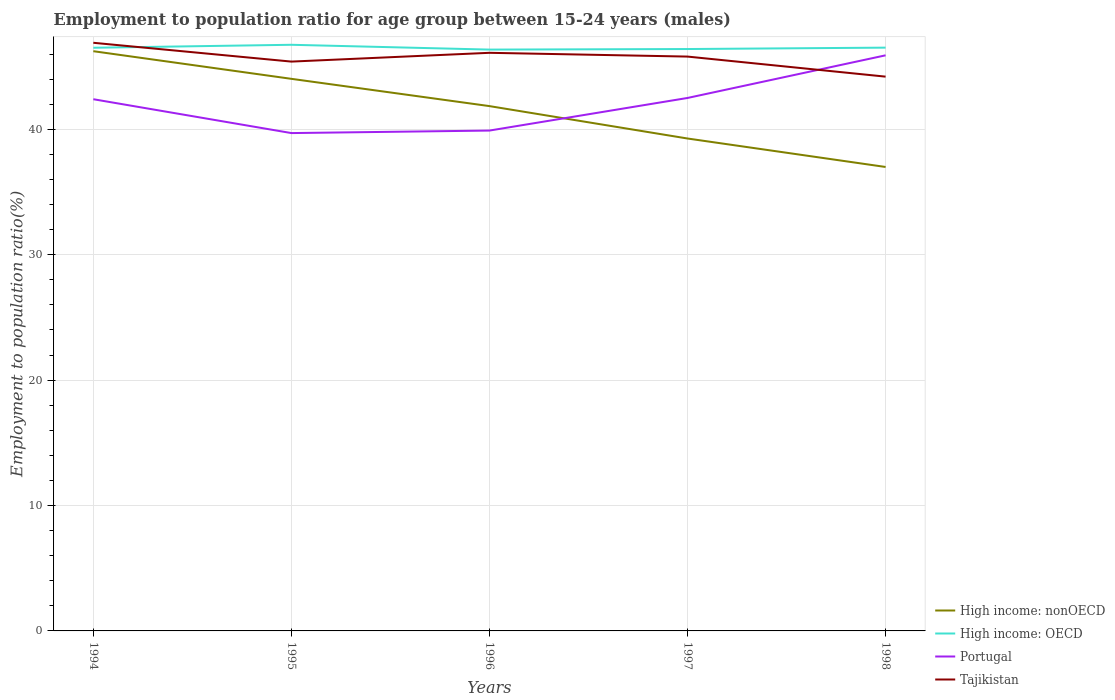How many different coloured lines are there?
Offer a very short reply. 4. Is the number of lines equal to the number of legend labels?
Keep it short and to the point. Yes. Across all years, what is the maximum employment to population ratio in High income: OECD?
Give a very brief answer. 46.36. What is the total employment to population ratio in High income: OECD in the graph?
Provide a succinct answer. -0.24. What is the difference between the highest and the second highest employment to population ratio in High income: OECD?
Provide a succinct answer. 0.38. What is the difference between the highest and the lowest employment to population ratio in Portugal?
Provide a succinct answer. 3. How many years are there in the graph?
Provide a succinct answer. 5. What is the difference between two consecutive major ticks on the Y-axis?
Provide a short and direct response. 10. Are the values on the major ticks of Y-axis written in scientific E-notation?
Give a very brief answer. No. Does the graph contain any zero values?
Ensure brevity in your answer.  No. Does the graph contain grids?
Your response must be concise. Yes. Where does the legend appear in the graph?
Offer a terse response. Bottom right. How many legend labels are there?
Ensure brevity in your answer.  4. How are the legend labels stacked?
Your answer should be compact. Vertical. What is the title of the graph?
Give a very brief answer. Employment to population ratio for age group between 15-24 years (males). What is the label or title of the Y-axis?
Make the answer very short. Employment to population ratio(%). What is the Employment to population ratio(%) of High income: nonOECD in 1994?
Keep it short and to the point. 46.23. What is the Employment to population ratio(%) in High income: OECD in 1994?
Give a very brief answer. 46.5. What is the Employment to population ratio(%) of Portugal in 1994?
Provide a short and direct response. 42.4. What is the Employment to population ratio(%) of Tajikistan in 1994?
Offer a very short reply. 46.9. What is the Employment to population ratio(%) in High income: nonOECD in 1995?
Provide a short and direct response. 44.03. What is the Employment to population ratio(%) of High income: OECD in 1995?
Keep it short and to the point. 46.74. What is the Employment to population ratio(%) of Portugal in 1995?
Your answer should be compact. 39.7. What is the Employment to population ratio(%) in Tajikistan in 1995?
Your response must be concise. 45.4. What is the Employment to population ratio(%) in High income: nonOECD in 1996?
Ensure brevity in your answer.  41.85. What is the Employment to population ratio(%) of High income: OECD in 1996?
Ensure brevity in your answer.  46.36. What is the Employment to population ratio(%) of Portugal in 1996?
Your answer should be compact. 39.9. What is the Employment to population ratio(%) of Tajikistan in 1996?
Ensure brevity in your answer.  46.1. What is the Employment to population ratio(%) in High income: nonOECD in 1997?
Offer a very short reply. 39.27. What is the Employment to population ratio(%) in High income: OECD in 1997?
Your answer should be very brief. 46.4. What is the Employment to population ratio(%) of Portugal in 1997?
Provide a succinct answer. 42.5. What is the Employment to population ratio(%) of Tajikistan in 1997?
Your answer should be compact. 45.8. What is the Employment to population ratio(%) in High income: nonOECD in 1998?
Give a very brief answer. 37. What is the Employment to population ratio(%) in High income: OECD in 1998?
Make the answer very short. 46.51. What is the Employment to population ratio(%) of Portugal in 1998?
Ensure brevity in your answer.  45.9. What is the Employment to population ratio(%) in Tajikistan in 1998?
Give a very brief answer. 44.2. Across all years, what is the maximum Employment to population ratio(%) in High income: nonOECD?
Your response must be concise. 46.23. Across all years, what is the maximum Employment to population ratio(%) of High income: OECD?
Provide a short and direct response. 46.74. Across all years, what is the maximum Employment to population ratio(%) in Portugal?
Make the answer very short. 45.9. Across all years, what is the maximum Employment to population ratio(%) in Tajikistan?
Ensure brevity in your answer.  46.9. Across all years, what is the minimum Employment to population ratio(%) of High income: nonOECD?
Offer a very short reply. 37. Across all years, what is the minimum Employment to population ratio(%) in High income: OECD?
Provide a short and direct response. 46.36. Across all years, what is the minimum Employment to population ratio(%) of Portugal?
Ensure brevity in your answer.  39.7. Across all years, what is the minimum Employment to population ratio(%) in Tajikistan?
Ensure brevity in your answer.  44.2. What is the total Employment to population ratio(%) in High income: nonOECD in the graph?
Give a very brief answer. 208.37. What is the total Employment to population ratio(%) in High income: OECD in the graph?
Your answer should be very brief. 232.52. What is the total Employment to population ratio(%) of Portugal in the graph?
Ensure brevity in your answer.  210.4. What is the total Employment to population ratio(%) in Tajikistan in the graph?
Your response must be concise. 228.4. What is the difference between the Employment to population ratio(%) of High income: nonOECD in 1994 and that in 1995?
Ensure brevity in your answer.  2.2. What is the difference between the Employment to population ratio(%) in High income: OECD in 1994 and that in 1995?
Keep it short and to the point. -0.24. What is the difference between the Employment to population ratio(%) of Portugal in 1994 and that in 1995?
Provide a succinct answer. 2.7. What is the difference between the Employment to population ratio(%) in High income: nonOECD in 1994 and that in 1996?
Keep it short and to the point. 4.38. What is the difference between the Employment to population ratio(%) of High income: OECD in 1994 and that in 1996?
Provide a short and direct response. 0.15. What is the difference between the Employment to population ratio(%) of Tajikistan in 1994 and that in 1996?
Give a very brief answer. 0.8. What is the difference between the Employment to population ratio(%) of High income: nonOECD in 1994 and that in 1997?
Ensure brevity in your answer.  6.96. What is the difference between the Employment to population ratio(%) in High income: OECD in 1994 and that in 1997?
Your answer should be very brief. 0.1. What is the difference between the Employment to population ratio(%) of Portugal in 1994 and that in 1997?
Ensure brevity in your answer.  -0.1. What is the difference between the Employment to population ratio(%) of Tajikistan in 1994 and that in 1997?
Provide a succinct answer. 1.1. What is the difference between the Employment to population ratio(%) in High income: nonOECD in 1994 and that in 1998?
Ensure brevity in your answer.  9.23. What is the difference between the Employment to population ratio(%) in High income: OECD in 1994 and that in 1998?
Ensure brevity in your answer.  -0.01. What is the difference between the Employment to population ratio(%) in High income: nonOECD in 1995 and that in 1996?
Provide a short and direct response. 2.17. What is the difference between the Employment to population ratio(%) of High income: OECD in 1995 and that in 1996?
Provide a succinct answer. 0.38. What is the difference between the Employment to population ratio(%) of Portugal in 1995 and that in 1996?
Keep it short and to the point. -0.2. What is the difference between the Employment to population ratio(%) of Tajikistan in 1995 and that in 1996?
Your answer should be compact. -0.7. What is the difference between the Employment to population ratio(%) in High income: nonOECD in 1995 and that in 1997?
Provide a short and direct response. 4.76. What is the difference between the Employment to population ratio(%) in High income: OECD in 1995 and that in 1997?
Provide a succinct answer. 0.34. What is the difference between the Employment to population ratio(%) in Portugal in 1995 and that in 1997?
Your response must be concise. -2.8. What is the difference between the Employment to population ratio(%) in Tajikistan in 1995 and that in 1997?
Provide a succinct answer. -0.4. What is the difference between the Employment to population ratio(%) in High income: nonOECD in 1995 and that in 1998?
Provide a short and direct response. 7.03. What is the difference between the Employment to population ratio(%) of High income: OECD in 1995 and that in 1998?
Ensure brevity in your answer.  0.23. What is the difference between the Employment to population ratio(%) of High income: nonOECD in 1996 and that in 1997?
Provide a succinct answer. 2.58. What is the difference between the Employment to population ratio(%) of High income: OECD in 1996 and that in 1997?
Make the answer very short. -0.04. What is the difference between the Employment to population ratio(%) of Tajikistan in 1996 and that in 1997?
Make the answer very short. 0.3. What is the difference between the Employment to population ratio(%) of High income: nonOECD in 1996 and that in 1998?
Your answer should be compact. 4.85. What is the difference between the Employment to population ratio(%) of High income: OECD in 1996 and that in 1998?
Your answer should be very brief. -0.16. What is the difference between the Employment to population ratio(%) in Portugal in 1996 and that in 1998?
Make the answer very short. -6. What is the difference between the Employment to population ratio(%) of High income: nonOECD in 1997 and that in 1998?
Provide a short and direct response. 2.27. What is the difference between the Employment to population ratio(%) in High income: OECD in 1997 and that in 1998?
Provide a short and direct response. -0.11. What is the difference between the Employment to population ratio(%) of High income: nonOECD in 1994 and the Employment to population ratio(%) of High income: OECD in 1995?
Give a very brief answer. -0.51. What is the difference between the Employment to population ratio(%) in High income: nonOECD in 1994 and the Employment to population ratio(%) in Portugal in 1995?
Your answer should be very brief. 6.53. What is the difference between the Employment to population ratio(%) in High income: nonOECD in 1994 and the Employment to population ratio(%) in Tajikistan in 1995?
Make the answer very short. 0.83. What is the difference between the Employment to population ratio(%) in High income: OECD in 1994 and the Employment to population ratio(%) in Portugal in 1995?
Provide a short and direct response. 6.8. What is the difference between the Employment to population ratio(%) of High income: OECD in 1994 and the Employment to population ratio(%) of Tajikistan in 1995?
Offer a terse response. 1.1. What is the difference between the Employment to population ratio(%) in High income: nonOECD in 1994 and the Employment to population ratio(%) in High income: OECD in 1996?
Provide a short and direct response. -0.13. What is the difference between the Employment to population ratio(%) of High income: nonOECD in 1994 and the Employment to population ratio(%) of Portugal in 1996?
Your answer should be compact. 6.33. What is the difference between the Employment to population ratio(%) in High income: nonOECD in 1994 and the Employment to population ratio(%) in Tajikistan in 1996?
Offer a terse response. 0.13. What is the difference between the Employment to population ratio(%) of High income: OECD in 1994 and the Employment to population ratio(%) of Portugal in 1996?
Keep it short and to the point. 6.6. What is the difference between the Employment to population ratio(%) of High income: OECD in 1994 and the Employment to population ratio(%) of Tajikistan in 1996?
Your answer should be compact. 0.4. What is the difference between the Employment to population ratio(%) in Portugal in 1994 and the Employment to population ratio(%) in Tajikistan in 1996?
Keep it short and to the point. -3.7. What is the difference between the Employment to population ratio(%) in High income: nonOECD in 1994 and the Employment to population ratio(%) in High income: OECD in 1997?
Ensure brevity in your answer.  -0.17. What is the difference between the Employment to population ratio(%) of High income: nonOECD in 1994 and the Employment to population ratio(%) of Portugal in 1997?
Make the answer very short. 3.73. What is the difference between the Employment to population ratio(%) in High income: nonOECD in 1994 and the Employment to population ratio(%) in Tajikistan in 1997?
Provide a succinct answer. 0.43. What is the difference between the Employment to population ratio(%) in High income: OECD in 1994 and the Employment to population ratio(%) in Portugal in 1997?
Offer a terse response. 4. What is the difference between the Employment to population ratio(%) in High income: OECD in 1994 and the Employment to population ratio(%) in Tajikistan in 1997?
Provide a succinct answer. 0.7. What is the difference between the Employment to population ratio(%) in Portugal in 1994 and the Employment to population ratio(%) in Tajikistan in 1997?
Keep it short and to the point. -3.4. What is the difference between the Employment to population ratio(%) in High income: nonOECD in 1994 and the Employment to population ratio(%) in High income: OECD in 1998?
Make the answer very short. -0.28. What is the difference between the Employment to population ratio(%) in High income: nonOECD in 1994 and the Employment to population ratio(%) in Portugal in 1998?
Make the answer very short. 0.33. What is the difference between the Employment to population ratio(%) of High income: nonOECD in 1994 and the Employment to population ratio(%) of Tajikistan in 1998?
Your response must be concise. 2.03. What is the difference between the Employment to population ratio(%) in High income: OECD in 1994 and the Employment to population ratio(%) in Portugal in 1998?
Offer a terse response. 0.6. What is the difference between the Employment to population ratio(%) of High income: OECD in 1994 and the Employment to population ratio(%) of Tajikistan in 1998?
Provide a short and direct response. 2.3. What is the difference between the Employment to population ratio(%) of Portugal in 1994 and the Employment to population ratio(%) of Tajikistan in 1998?
Provide a short and direct response. -1.8. What is the difference between the Employment to population ratio(%) in High income: nonOECD in 1995 and the Employment to population ratio(%) in High income: OECD in 1996?
Offer a very short reply. -2.33. What is the difference between the Employment to population ratio(%) of High income: nonOECD in 1995 and the Employment to population ratio(%) of Portugal in 1996?
Provide a short and direct response. 4.13. What is the difference between the Employment to population ratio(%) of High income: nonOECD in 1995 and the Employment to population ratio(%) of Tajikistan in 1996?
Provide a succinct answer. -2.07. What is the difference between the Employment to population ratio(%) in High income: OECD in 1995 and the Employment to population ratio(%) in Portugal in 1996?
Ensure brevity in your answer.  6.84. What is the difference between the Employment to population ratio(%) of High income: OECD in 1995 and the Employment to population ratio(%) of Tajikistan in 1996?
Give a very brief answer. 0.64. What is the difference between the Employment to population ratio(%) of Portugal in 1995 and the Employment to population ratio(%) of Tajikistan in 1996?
Provide a short and direct response. -6.4. What is the difference between the Employment to population ratio(%) of High income: nonOECD in 1995 and the Employment to population ratio(%) of High income: OECD in 1997?
Provide a short and direct response. -2.38. What is the difference between the Employment to population ratio(%) in High income: nonOECD in 1995 and the Employment to population ratio(%) in Portugal in 1997?
Provide a short and direct response. 1.53. What is the difference between the Employment to population ratio(%) in High income: nonOECD in 1995 and the Employment to population ratio(%) in Tajikistan in 1997?
Provide a short and direct response. -1.77. What is the difference between the Employment to population ratio(%) of High income: OECD in 1995 and the Employment to population ratio(%) of Portugal in 1997?
Make the answer very short. 4.24. What is the difference between the Employment to population ratio(%) of High income: OECD in 1995 and the Employment to population ratio(%) of Tajikistan in 1997?
Keep it short and to the point. 0.94. What is the difference between the Employment to population ratio(%) of High income: nonOECD in 1995 and the Employment to population ratio(%) of High income: OECD in 1998?
Provide a succinct answer. -2.49. What is the difference between the Employment to population ratio(%) in High income: nonOECD in 1995 and the Employment to population ratio(%) in Portugal in 1998?
Make the answer very short. -1.87. What is the difference between the Employment to population ratio(%) in High income: nonOECD in 1995 and the Employment to population ratio(%) in Tajikistan in 1998?
Your answer should be compact. -0.17. What is the difference between the Employment to population ratio(%) of High income: OECD in 1995 and the Employment to population ratio(%) of Portugal in 1998?
Your answer should be very brief. 0.84. What is the difference between the Employment to population ratio(%) of High income: OECD in 1995 and the Employment to population ratio(%) of Tajikistan in 1998?
Offer a terse response. 2.54. What is the difference between the Employment to population ratio(%) in High income: nonOECD in 1996 and the Employment to population ratio(%) in High income: OECD in 1997?
Ensure brevity in your answer.  -4.55. What is the difference between the Employment to population ratio(%) in High income: nonOECD in 1996 and the Employment to population ratio(%) in Portugal in 1997?
Provide a succinct answer. -0.65. What is the difference between the Employment to population ratio(%) of High income: nonOECD in 1996 and the Employment to population ratio(%) of Tajikistan in 1997?
Keep it short and to the point. -3.95. What is the difference between the Employment to population ratio(%) in High income: OECD in 1996 and the Employment to population ratio(%) in Portugal in 1997?
Offer a very short reply. 3.86. What is the difference between the Employment to population ratio(%) of High income: OECD in 1996 and the Employment to population ratio(%) of Tajikistan in 1997?
Provide a succinct answer. 0.56. What is the difference between the Employment to population ratio(%) in High income: nonOECD in 1996 and the Employment to population ratio(%) in High income: OECD in 1998?
Offer a terse response. -4.66. What is the difference between the Employment to population ratio(%) in High income: nonOECD in 1996 and the Employment to population ratio(%) in Portugal in 1998?
Give a very brief answer. -4.05. What is the difference between the Employment to population ratio(%) of High income: nonOECD in 1996 and the Employment to population ratio(%) of Tajikistan in 1998?
Ensure brevity in your answer.  -2.35. What is the difference between the Employment to population ratio(%) in High income: OECD in 1996 and the Employment to population ratio(%) in Portugal in 1998?
Your response must be concise. 0.46. What is the difference between the Employment to population ratio(%) of High income: OECD in 1996 and the Employment to population ratio(%) of Tajikistan in 1998?
Your answer should be very brief. 2.16. What is the difference between the Employment to population ratio(%) in High income: nonOECD in 1997 and the Employment to population ratio(%) in High income: OECD in 1998?
Provide a short and direct response. -7.25. What is the difference between the Employment to population ratio(%) of High income: nonOECD in 1997 and the Employment to population ratio(%) of Portugal in 1998?
Ensure brevity in your answer.  -6.63. What is the difference between the Employment to population ratio(%) of High income: nonOECD in 1997 and the Employment to population ratio(%) of Tajikistan in 1998?
Offer a very short reply. -4.93. What is the difference between the Employment to population ratio(%) of High income: OECD in 1997 and the Employment to population ratio(%) of Portugal in 1998?
Provide a succinct answer. 0.5. What is the difference between the Employment to population ratio(%) in High income: OECD in 1997 and the Employment to population ratio(%) in Tajikistan in 1998?
Ensure brevity in your answer.  2.2. What is the average Employment to population ratio(%) of High income: nonOECD per year?
Provide a short and direct response. 41.67. What is the average Employment to population ratio(%) in High income: OECD per year?
Keep it short and to the point. 46.5. What is the average Employment to population ratio(%) of Portugal per year?
Offer a terse response. 42.08. What is the average Employment to population ratio(%) of Tajikistan per year?
Your answer should be very brief. 45.68. In the year 1994, what is the difference between the Employment to population ratio(%) of High income: nonOECD and Employment to population ratio(%) of High income: OECD?
Make the answer very short. -0.27. In the year 1994, what is the difference between the Employment to population ratio(%) in High income: nonOECD and Employment to population ratio(%) in Portugal?
Offer a very short reply. 3.83. In the year 1994, what is the difference between the Employment to population ratio(%) in High income: nonOECD and Employment to population ratio(%) in Tajikistan?
Your answer should be compact. -0.67. In the year 1994, what is the difference between the Employment to population ratio(%) of High income: OECD and Employment to population ratio(%) of Portugal?
Offer a very short reply. 4.1. In the year 1994, what is the difference between the Employment to population ratio(%) of High income: OECD and Employment to population ratio(%) of Tajikistan?
Offer a very short reply. -0.4. In the year 1995, what is the difference between the Employment to population ratio(%) of High income: nonOECD and Employment to population ratio(%) of High income: OECD?
Provide a short and direct response. -2.72. In the year 1995, what is the difference between the Employment to population ratio(%) in High income: nonOECD and Employment to population ratio(%) in Portugal?
Keep it short and to the point. 4.33. In the year 1995, what is the difference between the Employment to population ratio(%) of High income: nonOECD and Employment to population ratio(%) of Tajikistan?
Make the answer very short. -1.37. In the year 1995, what is the difference between the Employment to population ratio(%) in High income: OECD and Employment to population ratio(%) in Portugal?
Make the answer very short. 7.04. In the year 1995, what is the difference between the Employment to population ratio(%) in High income: OECD and Employment to population ratio(%) in Tajikistan?
Your answer should be compact. 1.34. In the year 1995, what is the difference between the Employment to population ratio(%) in Portugal and Employment to population ratio(%) in Tajikistan?
Offer a terse response. -5.7. In the year 1996, what is the difference between the Employment to population ratio(%) in High income: nonOECD and Employment to population ratio(%) in High income: OECD?
Keep it short and to the point. -4.51. In the year 1996, what is the difference between the Employment to population ratio(%) in High income: nonOECD and Employment to population ratio(%) in Portugal?
Provide a short and direct response. 1.95. In the year 1996, what is the difference between the Employment to population ratio(%) in High income: nonOECD and Employment to population ratio(%) in Tajikistan?
Give a very brief answer. -4.25. In the year 1996, what is the difference between the Employment to population ratio(%) of High income: OECD and Employment to population ratio(%) of Portugal?
Your answer should be very brief. 6.46. In the year 1996, what is the difference between the Employment to population ratio(%) in High income: OECD and Employment to population ratio(%) in Tajikistan?
Your response must be concise. 0.26. In the year 1997, what is the difference between the Employment to population ratio(%) in High income: nonOECD and Employment to population ratio(%) in High income: OECD?
Offer a terse response. -7.13. In the year 1997, what is the difference between the Employment to population ratio(%) in High income: nonOECD and Employment to population ratio(%) in Portugal?
Provide a short and direct response. -3.23. In the year 1997, what is the difference between the Employment to population ratio(%) in High income: nonOECD and Employment to population ratio(%) in Tajikistan?
Your response must be concise. -6.53. In the year 1997, what is the difference between the Employment to population ratio(%) in High income: OECD and Employment to population ratio(%) in Portugal?
Make the answer very short. 3.9. In the year 1997, what is the difference between the Employment to population ratio(%) of High income: OECD and Employment to population ratio(%) of Tajikistan?
Keep it short and to the point. 0.6. In the year 1997, what is the difference between the Employment to population ratio(%) of Portugal and Employment to population ratio(%) of Tajikistan?
Provide a succinct answer. -3.3. In the year 1998, what is the difference between the Employment to population ratio(%) in High income: nonOECD and Employment to population ratio(%) in High income: OECD?
Ensure brevity in your answer.  -9.52. In the year 1998, what is the difference between the Employment to population ratio(%) in High income: nonOECD and Employment to population ratio(%) in Portugal?
Make the answer very short. -8.9. In the year 1998, what is the difference between the Employment to population ratio(%) of High income: nonOECD and Employment to population ratio(%) of Tajikistan?
Provide a short and direct response. -7.2. In the year 1998, what is the difference between the Employment to population ratio(%) of High income: OECD and Employment to population ratio(%) of Portugal?
Offer a very short reply. 0.61. In the year 1998, what is the difference between the Employment to population ratio(%) of High income: OECD and Employment to population ratio(%) of Tajikistan?
Your response must be concise. 2.31. What is the ratio of the Employment to population ratio(%) of High income: nonOECD in 1994 to that in 1995?
Offer a very short reply. 1.05. What is the ratio of the Employment to population ratio(%) in Portugal in 1994 to that in 1995?
Offer a very short reply. 1.07. What is the ratio of the Employment to population ratio(%) in Tajikistan in 1994 to that in 1995?
Make the answer very short. 1.03. What is the ratio of the Employment to population ratio(%) in High income: nonOECD in 1994 to that in 1996?
Your response must be concise. 1.1. What is the ratio of the Employment to population ratio(%) in Portugal in 1994 to that in 1996?
Give a very brief answer. 1.06. What is the ratio of the Employment to population ratio(%) in Tajikistan in 1994 to that in 1996?
Ensure brevity in your answer.  1.02. What is the ratio of the Employment to population ratio(%) of High income: nonOECD in 1994 to that in 1997?
Provide a short and direct response. 1.18. What is the ratio of the Employment to population ratio(%) in High income: OECD in 1994 to that in 1997?
Provide a short and direct response. 1. What is the ratio of the Employment to population ratio(%) in Portugal in 1994 to that in 1997?
Keep it short and to the point. 1. What is the ratio of the Employment to population ratio(%) of Tajikistan in 1994 to that in 1997?
Ensure brevity in your answer.  1.02. What is the ratio of the Employment to population ratio(%) in High income: nonOECD in 1994 to that in 1998?
Keep it short and to the point. 1.25. What is the ratio of the Employment to population ratio(%) of Portugal in 1994 to that in 1998?
Keep it short and to the point. 0.92. What is the ratio of the Employment to population ratio(%) in Tajikistan in 1994 to that in 1998?
Provide a short and direct response. 1.06. What is the ratio of the Employment to population ratio(%) in High income: nonOECD in 1995 to that in 1996?
Keep it short and to the point. 1.05. What is the ratio of the Employment to population ratio(%) of High income: OECD in 1995 to that in 1996?
Make the answer very short. 1.01. What is the ratio of the Employment to population ratio(%) in Portugal in 1995 to that in 1996?
Provide a succinct answer. 0.99. What is the ratio of the Employment to population ratio(%) of High income: nonOECD in 1995 to that in 1997?
Your response must be concise. 1.12. What is the ratio of the Employment to population ratio(%) of High income: OECD in 1995 to that in 1997?
Your answer should be very brief. 1.01. What is the ratio of the Employment to population ratio(%) in Portugal in 1995 to that in 1997?
Your answer should be very brief. 0.93. What is the ratio of the Employment to population ratio(%) of High income: nonOECD in 1995 to that in 1998?
Make the answer very short. 1.19. What is the ratio of the Employment to population ratio(%) of High income: OECD in 1995 to that in 1998?
Keep it short and to the point. 1. What is the ratio of the Employment to population ratio(%) of Portugal in 1995 to that in 1998?
Your response must be concise. 0.86. What is the ratio of the Employment to population ratio(%) in Tajikistan in 1995 to that in 1998?
Offer a very short reply. 1.03. What is the ratio of the Employment to population ratio(%) in High income: nonOECD in 1996 to that in 1997?
Offer a very short reply. 1.07. What is the ratio of the Employment to population ratio(%) in High income: OECD in 1996 to that in 1997?
Give a very brief answer. 1. What is the ratio of the Employment to population ratio(%) of Portugal in 1996 to that in 1997?
Ensure brevity in your answer.  0.94. What is the ratio of the Employment to population ratio(%) of Tajikistan in 1996 to that in 1997?
Make the answer very short. 1.01. What is the ratio of the Employment to population ratio(%) of High income: nonOECD in 1996 to that in 1998?
Your answer should be compact. 1.13. What is the ratio of the Employment to population ratio(%) in Portugal in 1996 to that in 1998?
Give a very brief answer. 0.87. What is the ratio of the Employment to population ratio(%) in Tajikistan in 1996 to that in 1998?
Offer a very short reply. 1.04. What is the ratio of the Employment to population ratio(%) of High income: nonOECD in 1997 to that in 1998?
Provide a succinct answer. 1.06. What is the ratio of the Employment to population ratio(%) of High income: OECD in 1997 to that in 1998?
Give a very brief answer. 1. What is the ratio of the Employment to population ratio(%) in Portugal in 1997 to that in 1998?
Your answer should be compact. 0.93. What is the ratio of the Employment to population ratio(%) of Tajikistan in 1997 to that in 1998?
Your answer should be compact. 1.04. What is the difference between the highest and the second highest Employment to population ratio(%) in High income: nonOECD?
Keep it short and to the point. 2.2. What is the difference between the highest and the second highest Employment to population ratio(%) in High income: OECD?
Make the answer very short. 0.23. What is the difference between the highest and the second highest Employment to population ratio(%) of Portugal?
Provide a succinct answer. 3.4. What is the difference between the highest and the second highest Employment to population ratio(%) of Tajikistan?
Offer a very short reply. 0.8. What is the difference between the highest and the lowest Employment to population ratio(%) of High income: nonOECD?
Offer a terse response. 9.23. What is the difference between the highest and the lowest Employment to population ratio(%) of High income: OECD?
Your response must be concise. 0.38. What is the difference between the highest and the lowest Employment to population ratio(%) of Portugal?
Offer a very short reply. 6.2. 